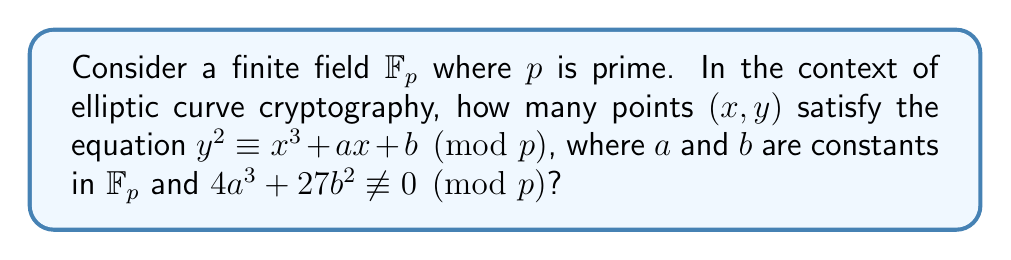Give your solution to this math problem. Let's approach this step-by-step:

1) First, recall Hasse's theorem for elliptic curves over finite fields. It states that the number of points $N$ on an elliptic curve over $\mathbb{F}_p$ satisfies:

   $$|N - (p + 1)| \leq 2\sqrt{p}$$

2) This means that the number of points is always close to $p + 1$.

3) To understand why, let's consider the structure of the curve:
   - For each $x \in \mathbb{F}_p$, we need to count how many $y$ satisfy the equation.
   - The right-hand side $x^3 + ax + b$ will give some value in $\mathbb{F}_p$.
   - If this value is a quadratic residue modulo $p$, there will be two $y$ values satisfying the equation.
   - If it's zero, there will be one $y$ value (namely, $y = 0$).
   - If it's a quadratic non-residue, there will be no $y$ values.

4) On average, about half of the elements in $\mathbb{F}_p$ are quadratic residues.

5) So, for about half of the $x$ values, we expect two points; for one $x$ value, we expect one point (when $y = 0$); and for the other half, we expect no points.

6) This gives us approximately:
   $$(p/2 * 2) + 1 + (p/2 * 0) = p + 1$$ points.

7) The exact number can deviate from this by at most $2\sqrt{p}$, as per Hasse's theorem.

8) Note: We also need to count the point at infinity, which is always on the curve.

Therefore, the number of points on the curve is $p + 1 \pm O(\sqrt{p})$.
Answer: $p + 1 \pm O(\sqrt{p})$ 